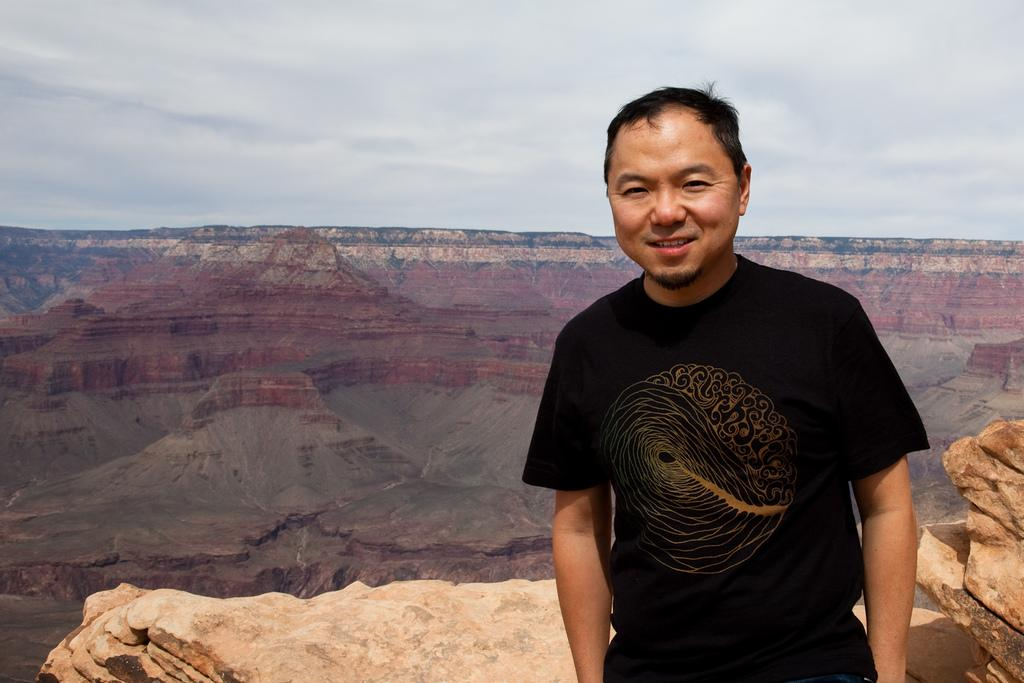Who is present in the image? There is a man in the image. Where is the man located in the image? The man is on the right side of the image. What is the man wearing? The man is wearing a t-shirt and trousers. What is the man's facial expression? The man is smiling. What can be seen in the background of the image? There are hills, stones, and the sky visible in the background of the image. What is the condition of the sky in the image? The sky is visible in the background of the image, and there are clouds present. What type of cake is the man holding in the image? There is no cake present in the image; the man is not holding anything. Can you tell me how many dogs are visible in the image? There are no dogs present in the image. 